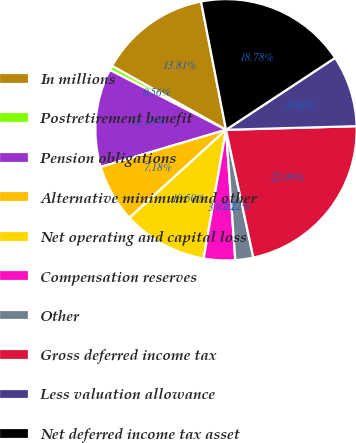Convert chart to OTSL. <chart><loc_0><loc_0><loc_500><loc_500><pie_chart><fcel>In millions<fcel>Postretirement benefit<fcel>Pension obligations<fcel>Alternative minimum and other<fcel>Net operating and capital loss<fcel>Compensation reserves<fcel>Other<fcel>Gross deferred income tax<fcel>Less valuation allowance<fcel>Net deferred income tax asset<nl><fcel>13.81%<fcel>0.56%<fcel>12.15%<fcel>7.18%<fcel>10.5%<fcel>3.87%<fcel>2.22%<fcel>22.09%<fcel>8.84%<fcel>18.78%<nl></chart> 